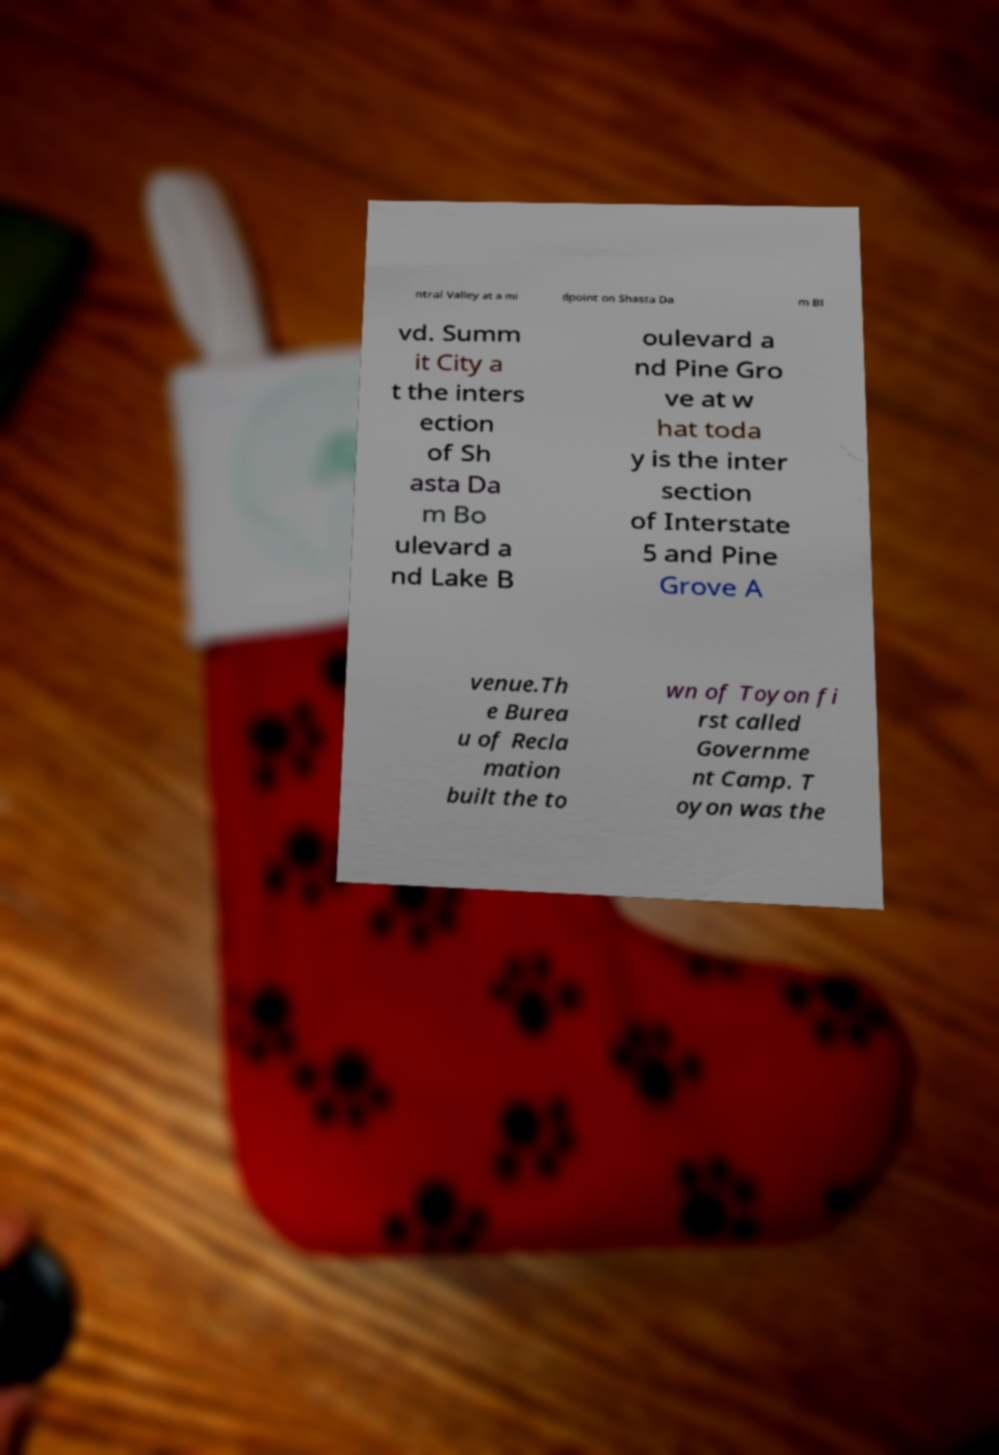What messages or text are displayed in this image? I need them in a readable, typed format. ntral Valley at a mi dpoint on Shasta Da m Bl vd. Summ it City a t the inters ection of Sh asta Da m Bo ulevard a nd Lake B oulevard a nd Pine Gro ve at w hat toda y is the inter section of Interstate 5 and Pine Grove A venue.Th e Burea u of Recla mation built the to wn of Toyon fi rst called Governme nt Camp. T oyon was the 